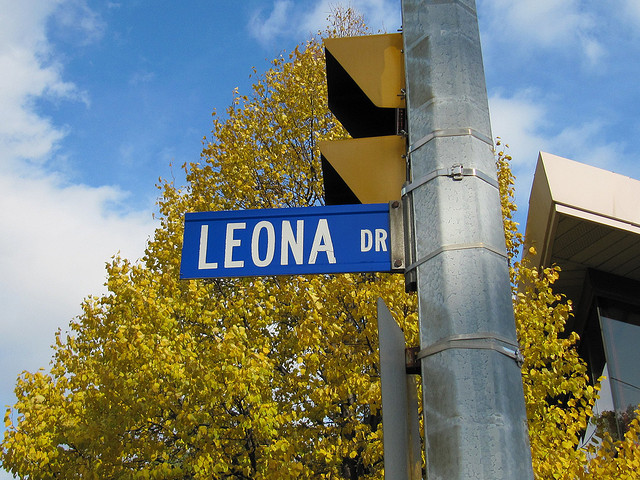Please transcribe the text information in this image. LEONA DR 